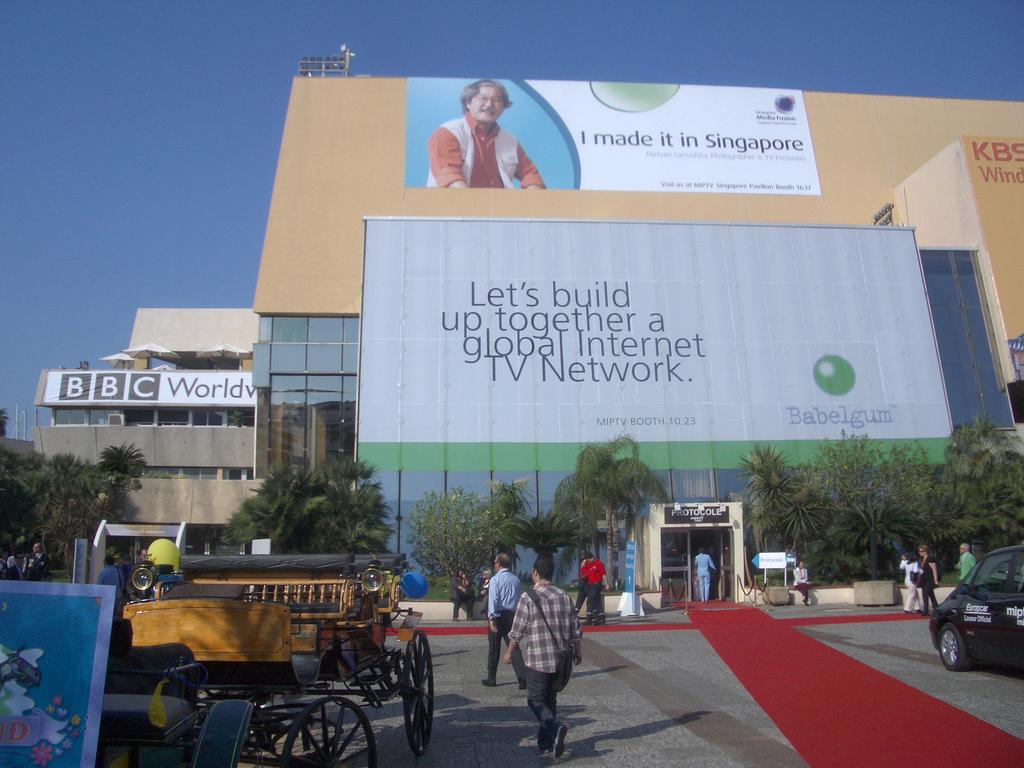<image>
Share a concise interpretation of the image provided. People walking into tour the BBC World building 